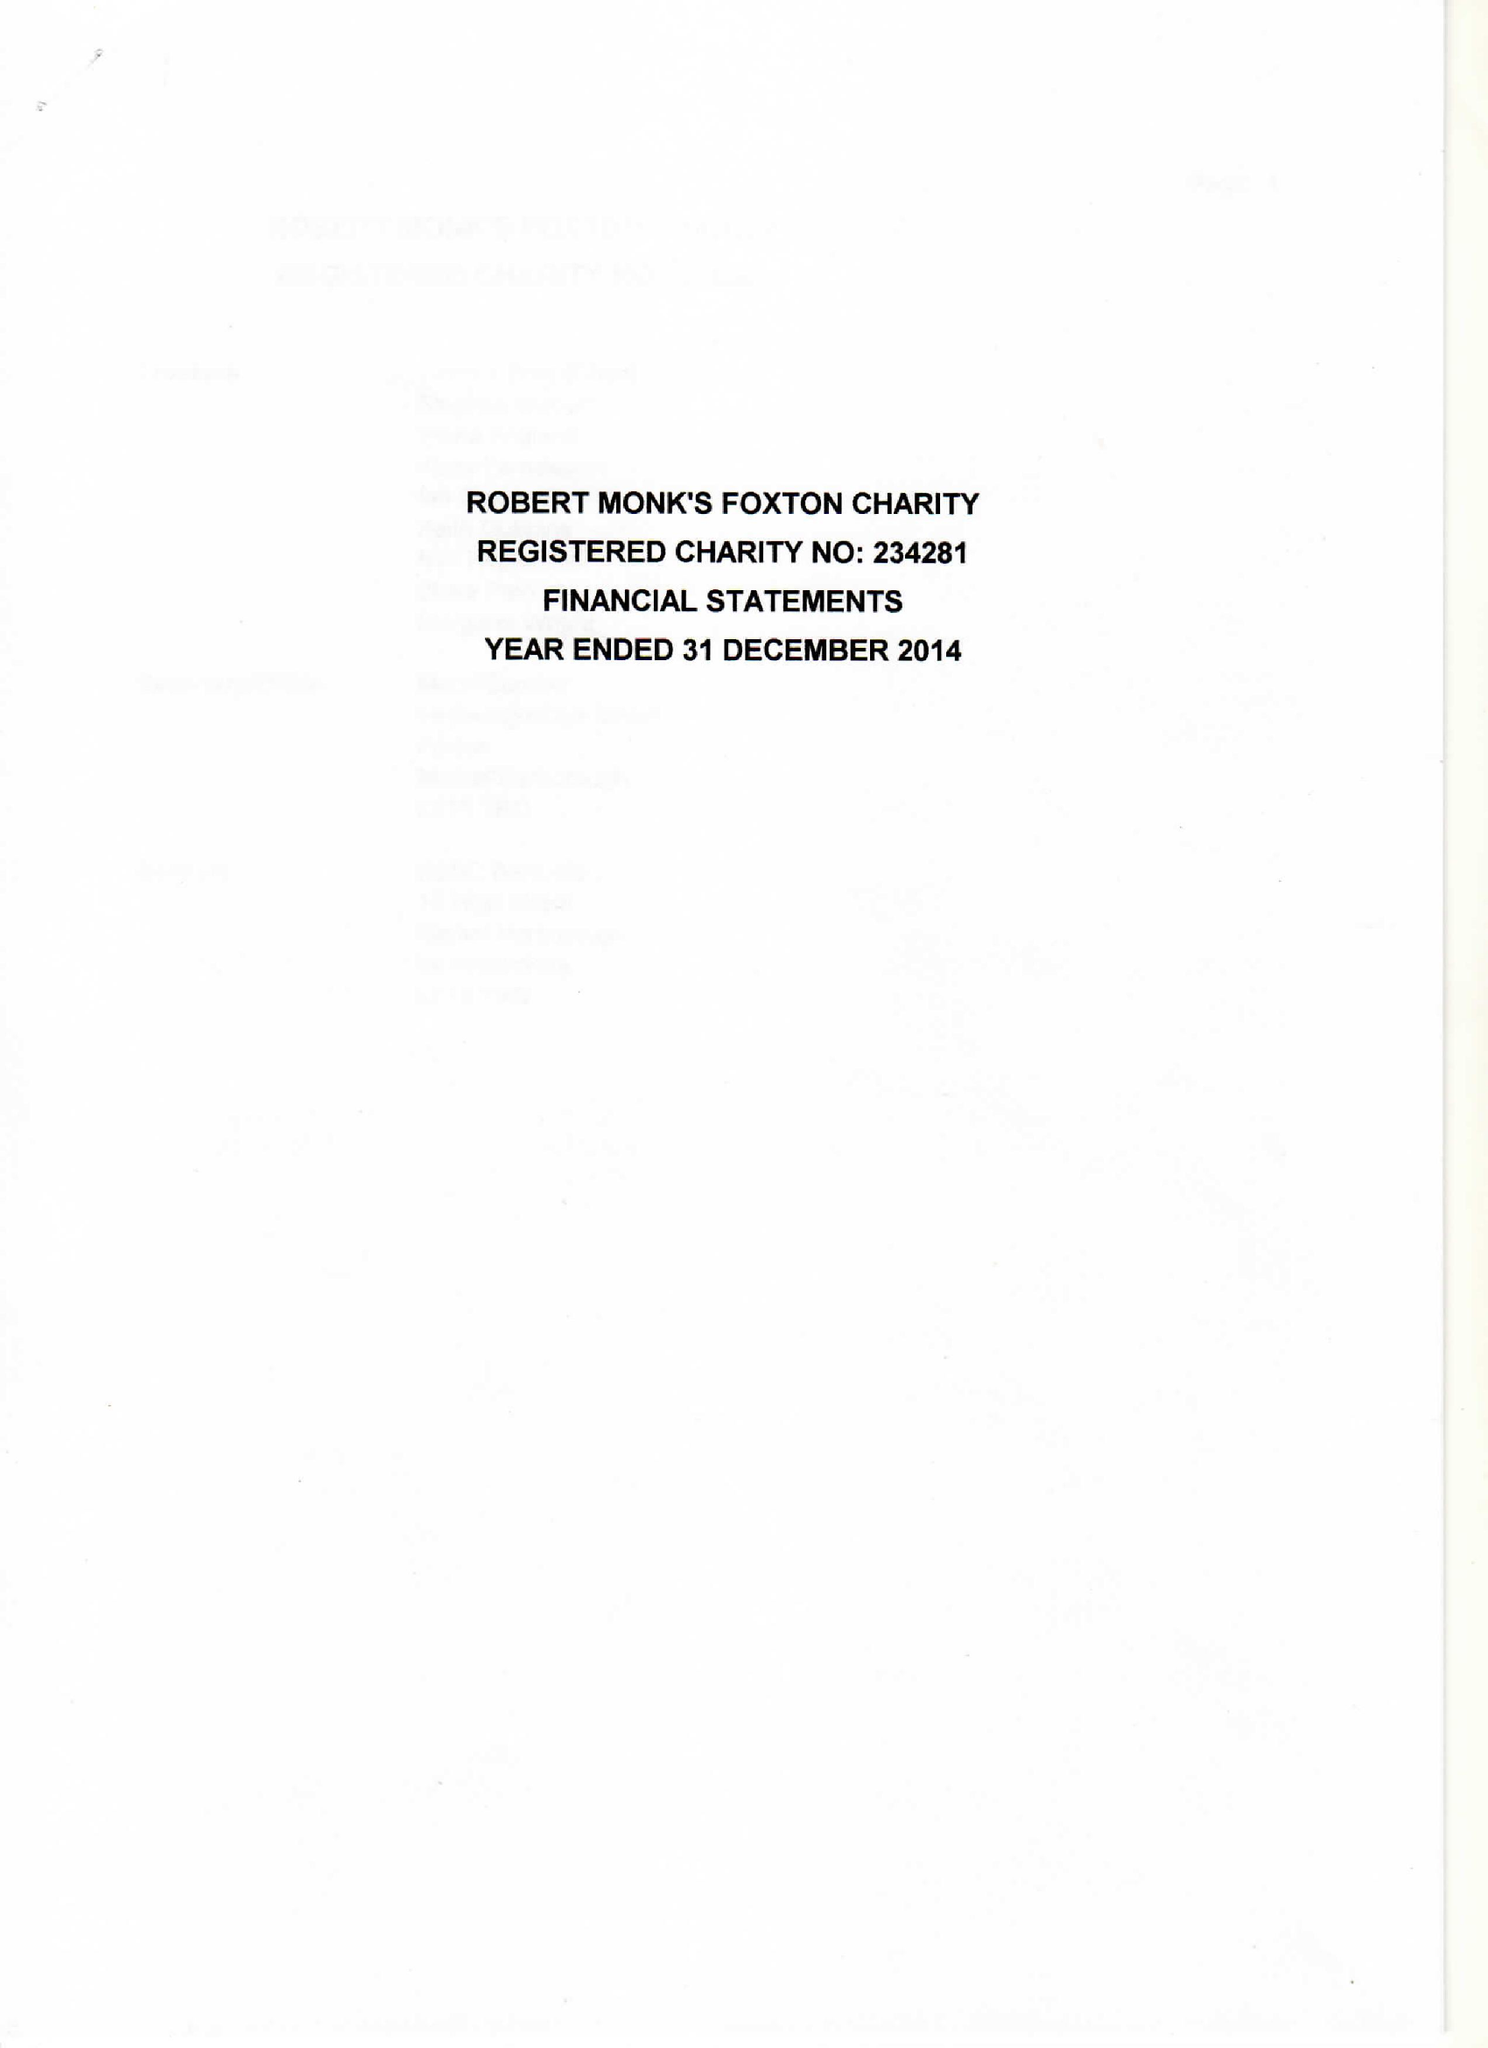What is the value for the spending_annually_in_british_pounds?
Answer the question using a single word or phrase. 25679.00 